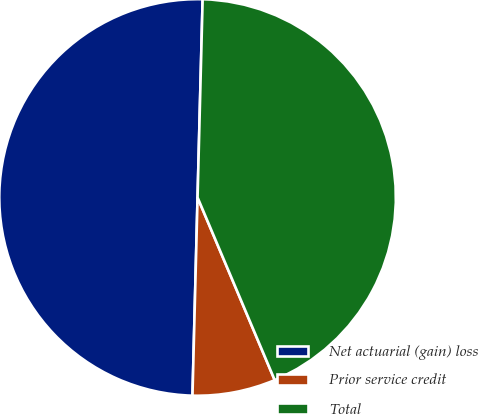Convert chart. <chart><loc_0><loc_0><loc_500><loc_500><pie_chart><fcel>Net actuarial (gain) loss<fcel>Prior service credit<fcel>Total<nl><fcel>50.0%<fcel>6.77%<fcel>43.23%<nl></chart> 